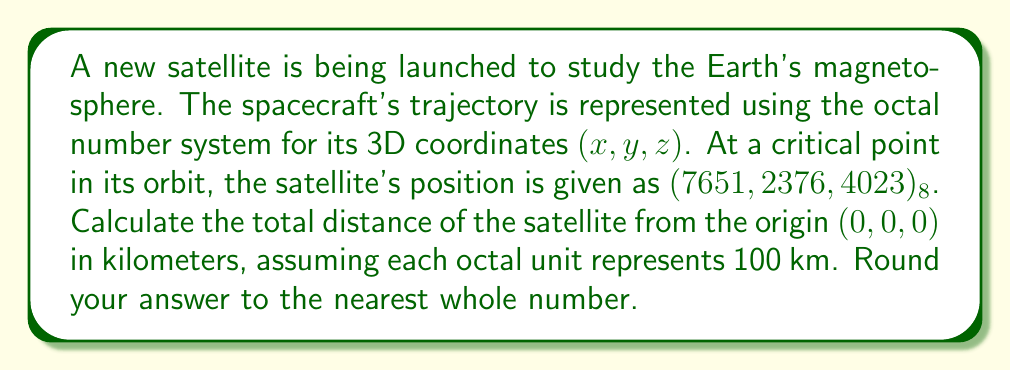Provide a solution to this math problem. To solve this problem, we need to follow these steps:

1) First, convert the octal coordinates to decimal:

   x: $(7651)_8 = 7 \cdot 8^3 + 6 \cdot 8^2 + 5 \cdot 8^1 + 1 \cdot 8^0 = 3584 + 384 + 40 + 1 = 4009_{10}$
   
   y: $(2376)_8 = 2 \cdot 8^3 + 3 \cdot 8^2 + 7 \cdot 8^1 + 6 \cdot 8^0 = 1024 + 192 + 56 + 6 = 1278_{10}$
   
   z: $(4023)_8 = 4 \cdot 8^3 + 0 \cdot 8^2 + 2 \cdot 8^1 + 3 \cdot 8^0 = 2048 + 0 + 16 + 3 = 2067_{10}$

2) Now, we need to multiply each coordinate by 100 km (as each octal unit represents 100 km):

   x: $4009 \cdot 100 = 400900$ km
   y: $1278 \cdot 100 = 127800$ km
   z: $2067 \cdot 100 = 206700$ km

3) To find the total distance from the origin, we use the 3D distance formula:

   $$d = \sqrt{x^2 + y^2 + z^2}$$

4) Substituting our values:

   $$d = \sqrt{400900^2 + 127800^2 + 206700^2}$$

5) Calculating:

   $$d = \sqrt{160720810000 + 16332840000 + 42725290000}$$
   $$d = \sqrt{219778940000}$$
   $$d \approx 468804.76$$ km

6) Rounding to the nearest whole number:

   $d \approx 468805$ km
Answer: 468805 km 